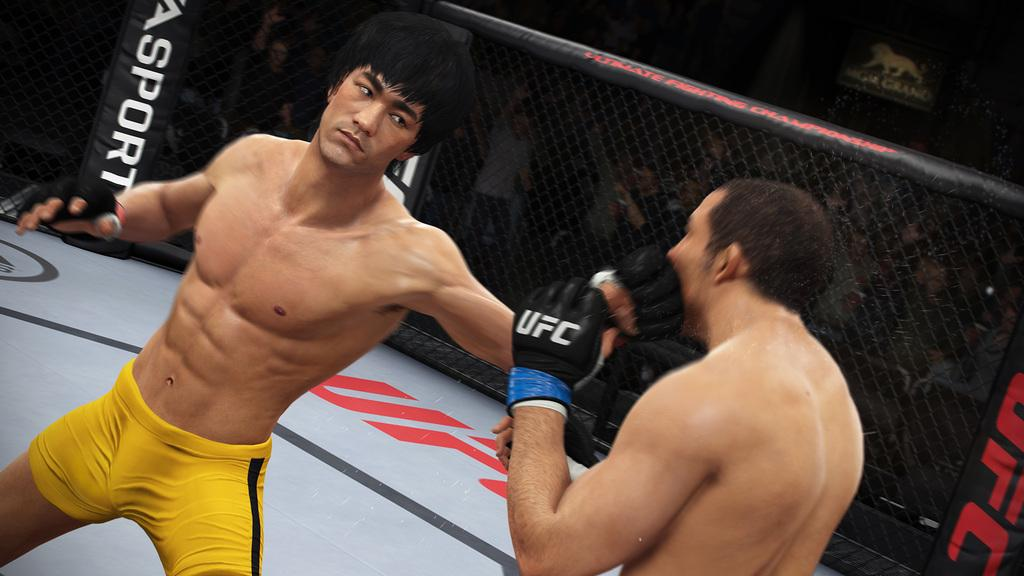<image>
Create a compact narrative representing the image presented. bruce lee fighting UFC for EA Sports game 